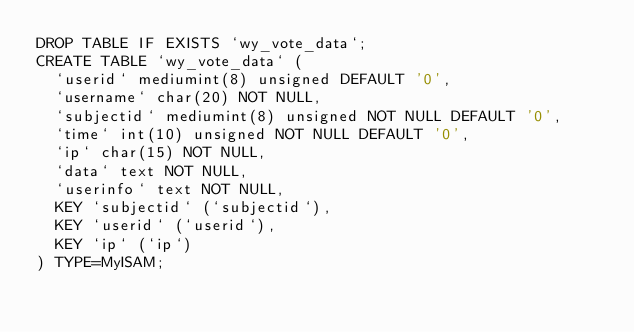<code> <loc_0><loc_0><loc_500><loc_500><_SQL_>DROP TABLE IF EXISTS `wy_vote_data`;
CREATE TABLE `wy_vote_data` (
  `userid` mediumint(8) unsigned DEFAULT '0',
  `username` char(20) NOT NULL,
  `subjectid` mediumint(8) unsigned NOT NULL DEFAULT '0',
  `time` int(10) unsigned NOT NULL DEFAULT '0',
  `ip` char(15) NOT NULL,
  `data` text NOT NULL,
  `userinfo` text NOT NULL,
  KEY `subjectid` (`subjectid`),
  KEY `userid` (`userid`),
  KEY `ip` (`ip`)
) TYPE=MyISAM;</code> 